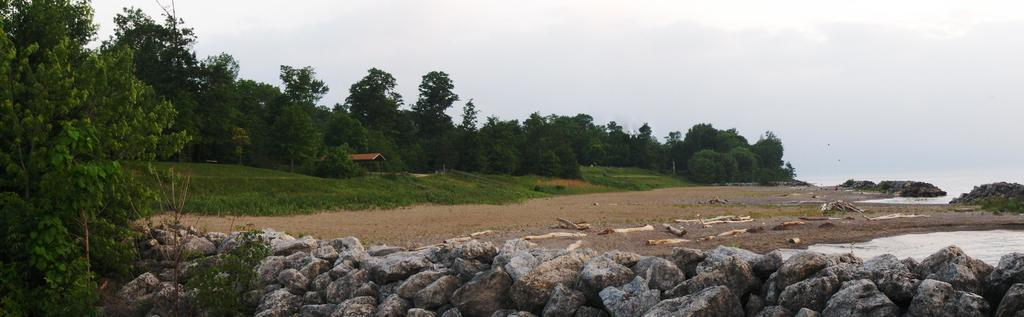What type of vegetation can be seen in the image? There are trees in the image. What is located on the right side of the image? There is water on the right side of the image. What can be found at the bottom of the image? Stones are visible at the bottom of the image. What is visible in the background of the image? The sky is visible in the background of the image. What type of structure is present in the image? There is a shed in the image. Who is the owner of the ocean in the image? There is no ocean present in the image, so it is not possible to determine the owner. Can you see a sock hanging from the trees in the image? There is no sock visible in the image; only trees, water, stones, sky, and a shed are present. 